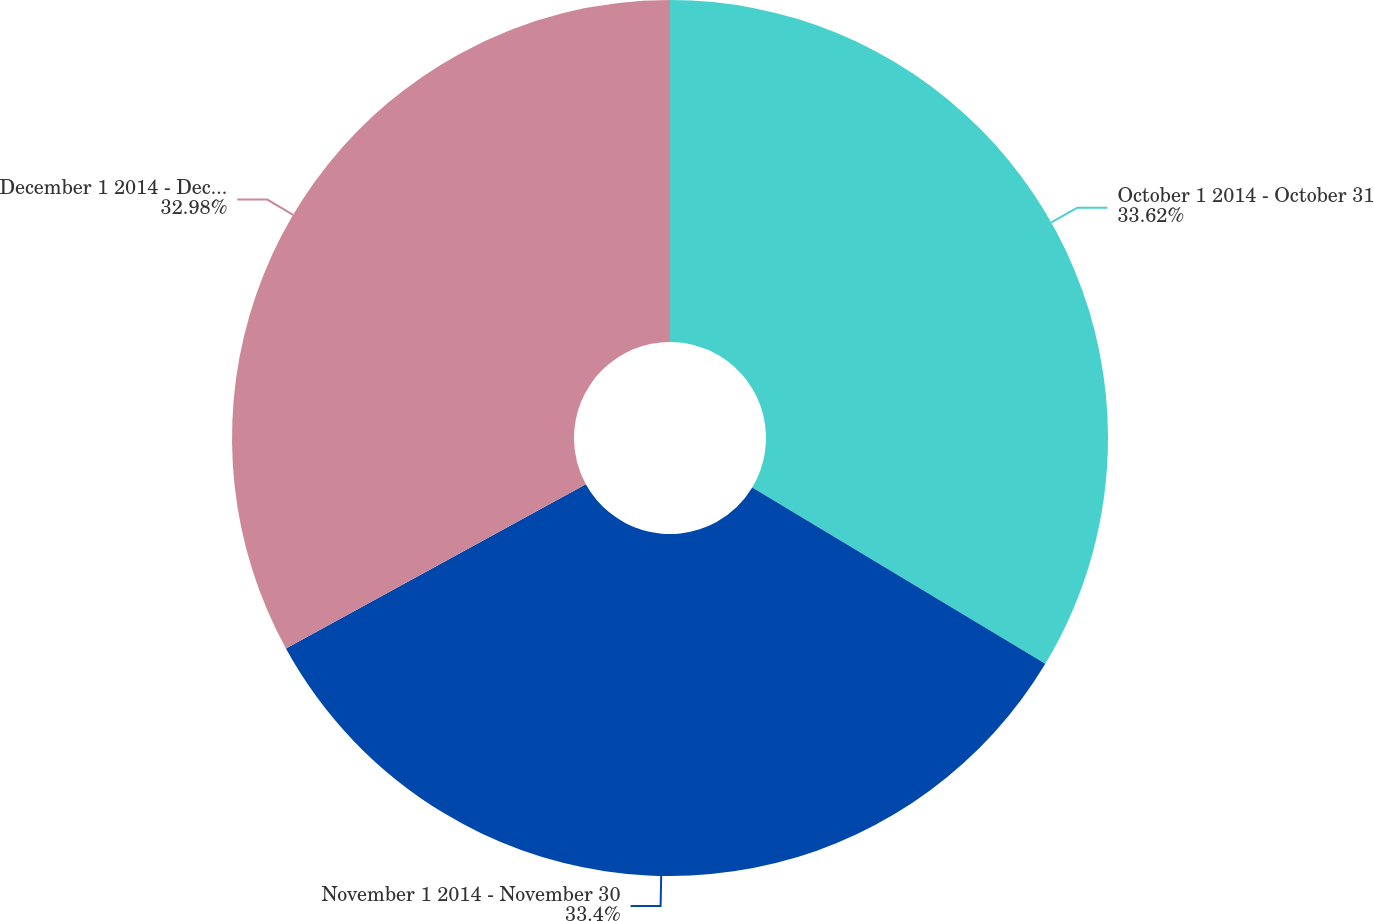Convert chart to OTSL. <chart><loc_0><loc_0><loc_500><loc_500><pie_chart><fcel>October 1 2014 - October 31<fcel>November 1 2014 - November 30<fcel>December 1 2014 - December 31<nl><fcel>33.62%<fcel>33.4%<fcel>32.98%<nl></chart> 